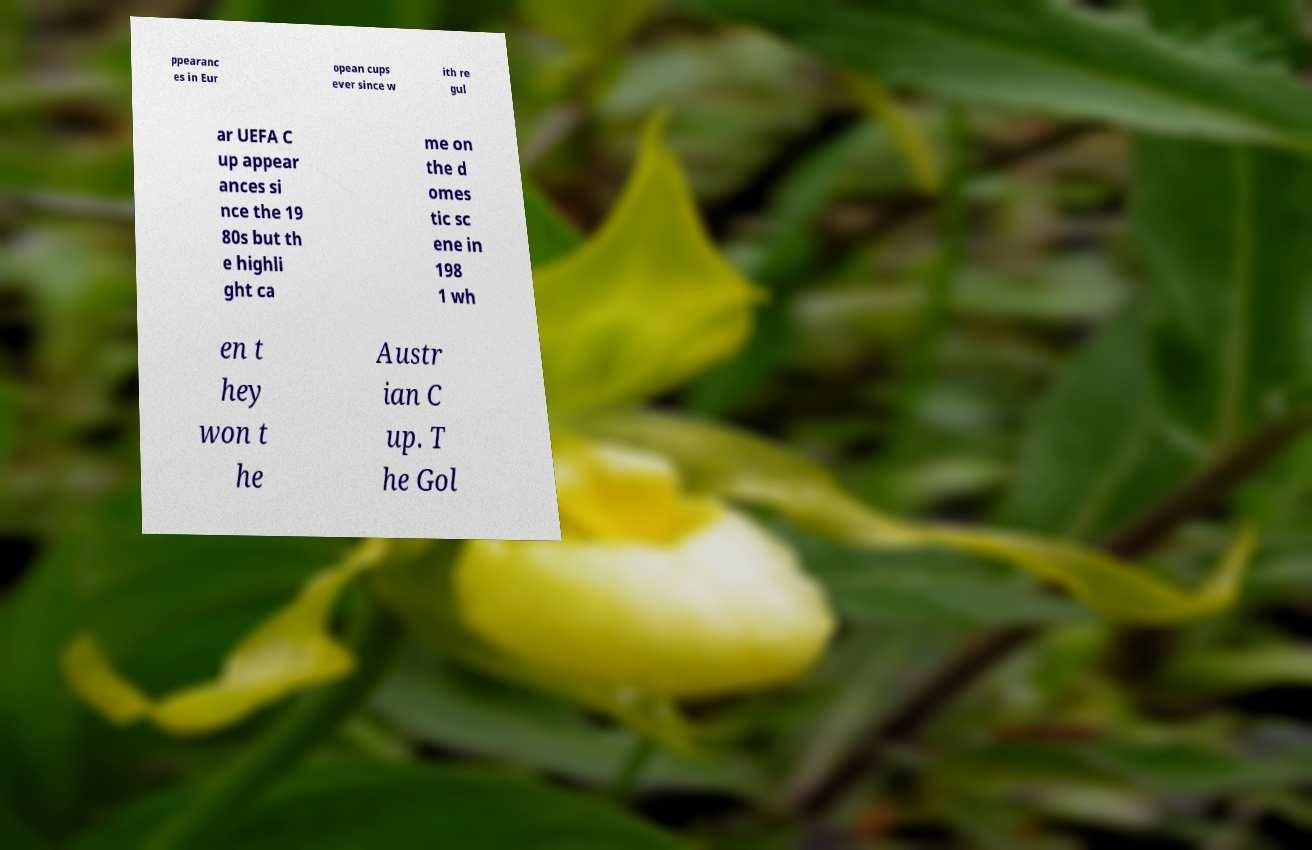There's text embedded in this image that I need extracted. Can you transcribe it verbatim? ppearanc es in Eur opean cups ever since w ith re gul ar UEFA C up appear ances si nce the 19 80s but th e highli ght ca me on the d omes tic sc ene in 198 1 wh en t hey won t he Austr ian C up. T he Gol 